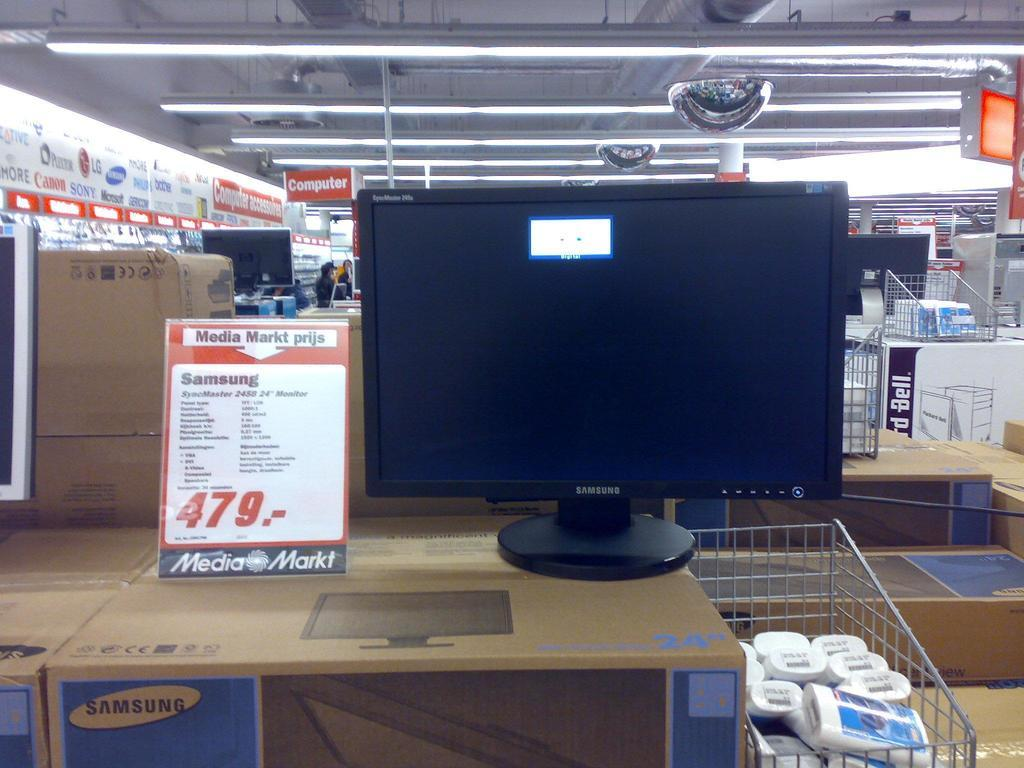Provide a one-sentence caption for the provided image. A computer on display with a sign indicating a sale price of $479.00. 